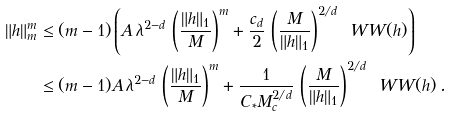Convert formula to latex. <formula><loc_0><loc_0><loc_500><loc_500>\| h \| _ { m } ^ { m } & \leq ( m - 1 ) \left ( A \, \lambda ^ { 2 - d } \, \left ( \frac { \| h \| _ { 1 } } { M } \right ) ^ { m } + \frac { c _ { d } } { 2 } \, \left ( \frac { M } { \| h \| _ { 1 } } \right ) ^ { 2 / d } \, \ W W ( h ) \right ) \\ & \leq ( m - 1 ) A \, \lambda ^ { 2 - d } \, \left ( \frac { \| h \| _ { 1 } } { M } \right ) ^ { m } + \frac { 1 } { C _ { * } M _ { c } ^ { 2 / d } } \, \left ( \frac { M } { \| h \| _ { 1 } } \right ) ^ { 2 / d } \, \ W W ( h ) \, .</formula> 